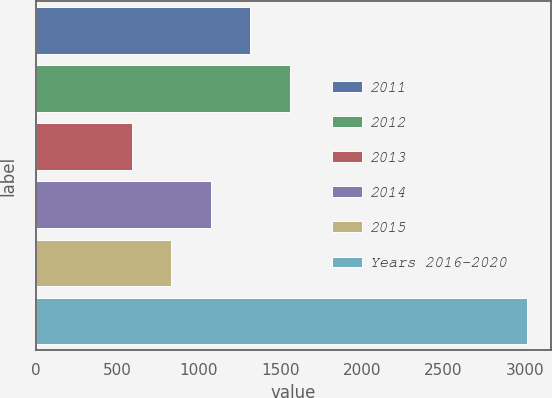<chart> <loc_0><loc_0><loc_500><loc_500><bar_chart><fcel>2011<fcel>2012<fcel>2013<fcel>2014<fcel>2015<fcel>Years 2016-2020<nl><fcel>1314.8<fcel>1557.4<fcel>587<fcel>1072.2<fcel>829.6<fcel>3013<nl></chart> 